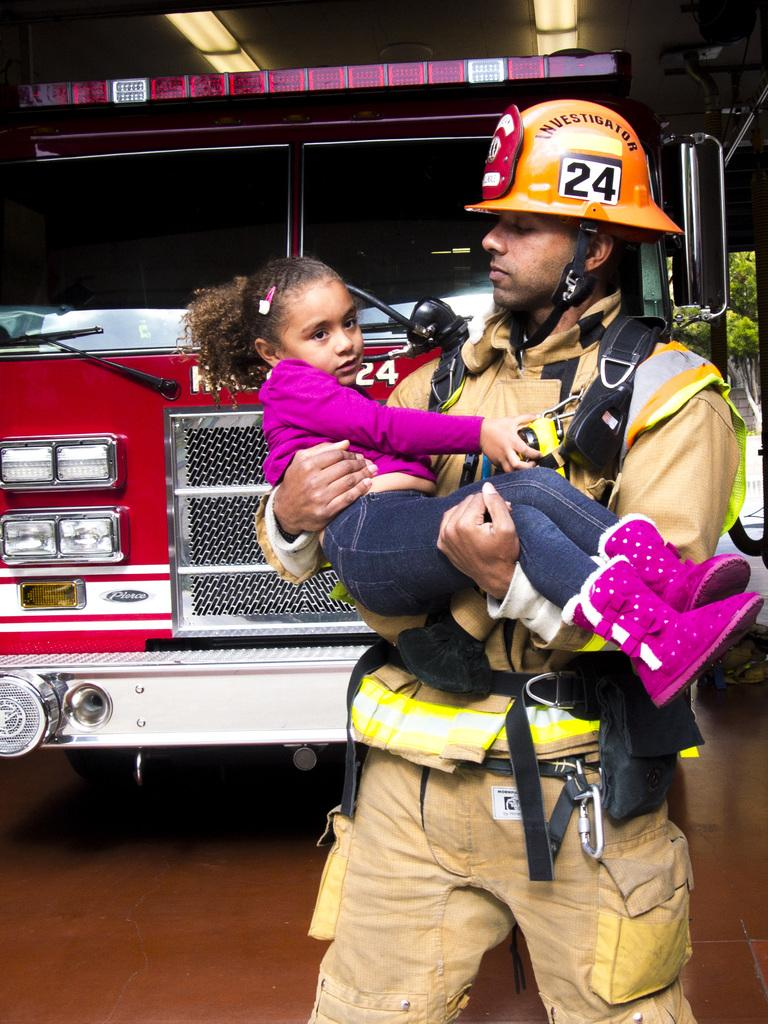What type of vehicle is in the image? There is a vehicle in the image, but the specific type is not mentioned. What color is the vehicle? The vehicle is red. How many people are in the image? There are two persons in the image. Can you describe the two people in the image? One of the persons is a man, and the other person is a kid. What is the man doing with the kid? The man is holding the kid. What type of farm animals can be seen in the image? There is no mention of farm animals in the image; it features a vehicle and two people. What title is given to the vehicle in the image? The specific title or name of the vehicle is not mentioned in the image. 